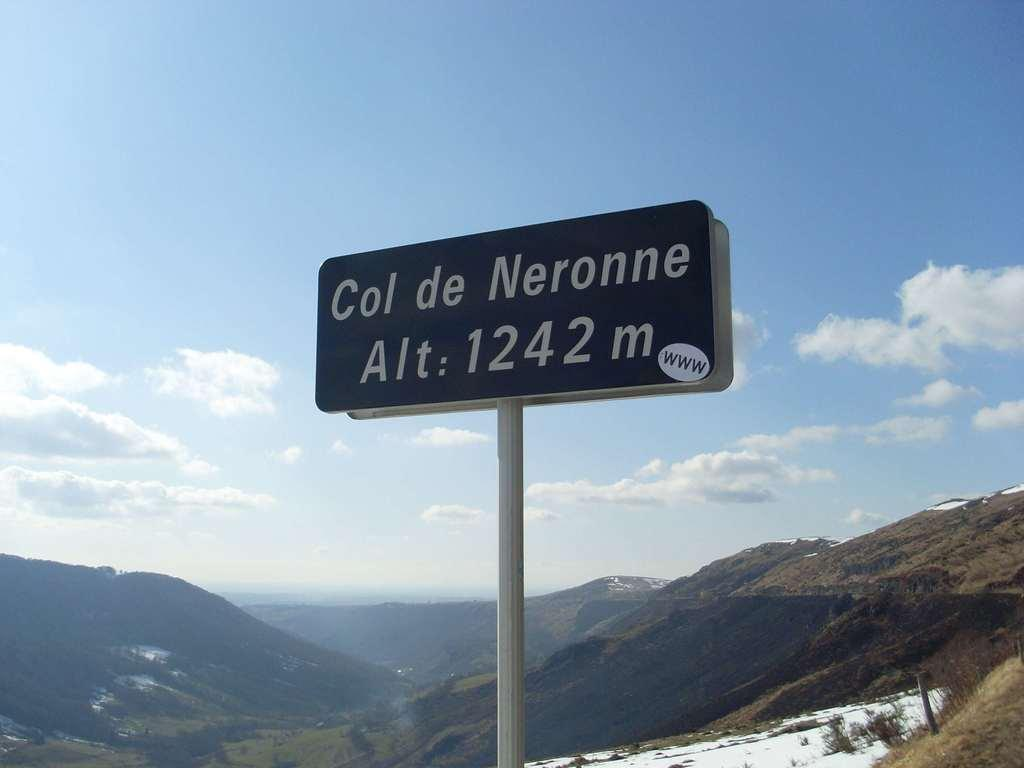Provide a one-sentence caption for the provided image. A Alt.sign near mountains called Col de Neronne. 